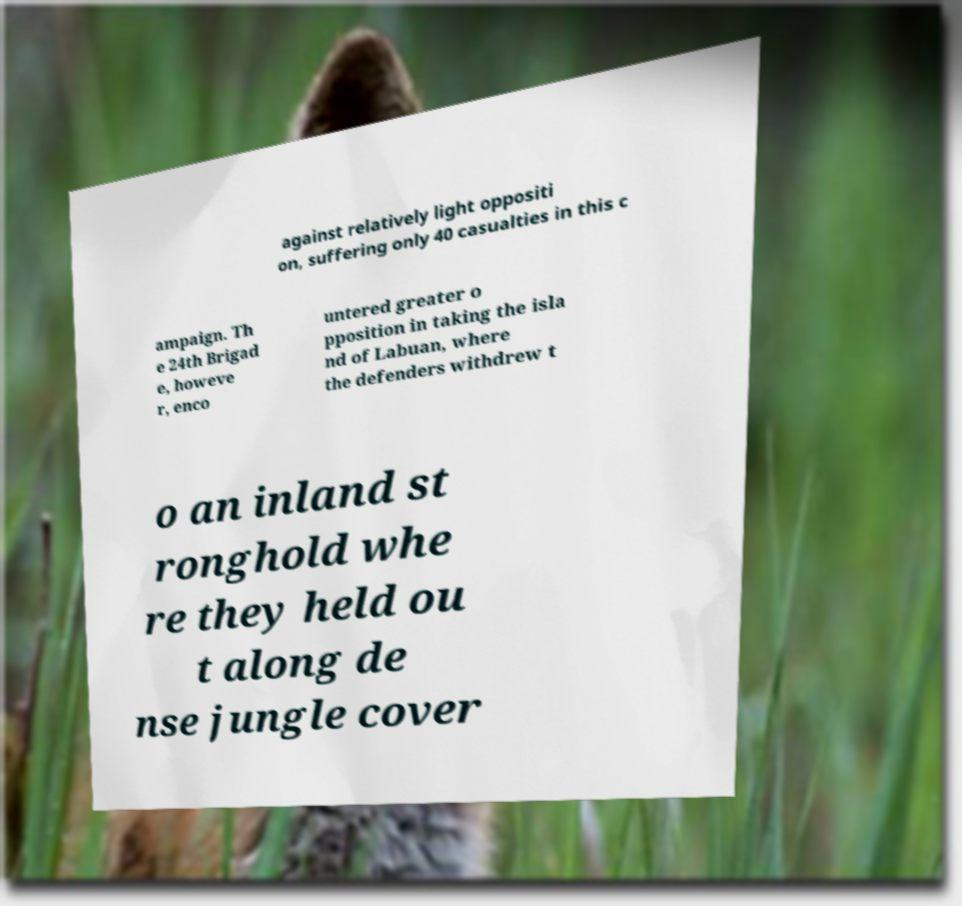There's text embedded in this image that I need extracted. Can you transcribe it verbatim? against relatively light oppositi on, suffering only 40 casualties in this c ampaign. Th e 24th Brigad e, howeve r, enco untered greater o pposition in taking the isla nd of Labuan, where the defenders withdrew t o an inland st ronghold whe re they held ou t along de nse jungle cover 